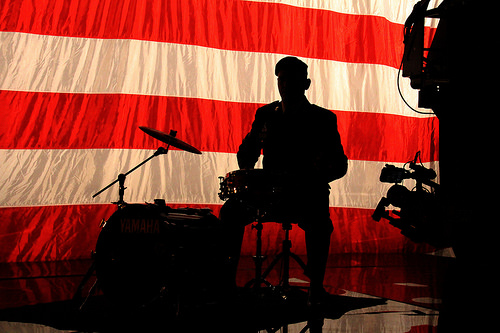<image>
Is there a man behind the drum? Yes. From this viewpoint, the man is positioned behind the drum, with the drum partially or fully occluding the man. 